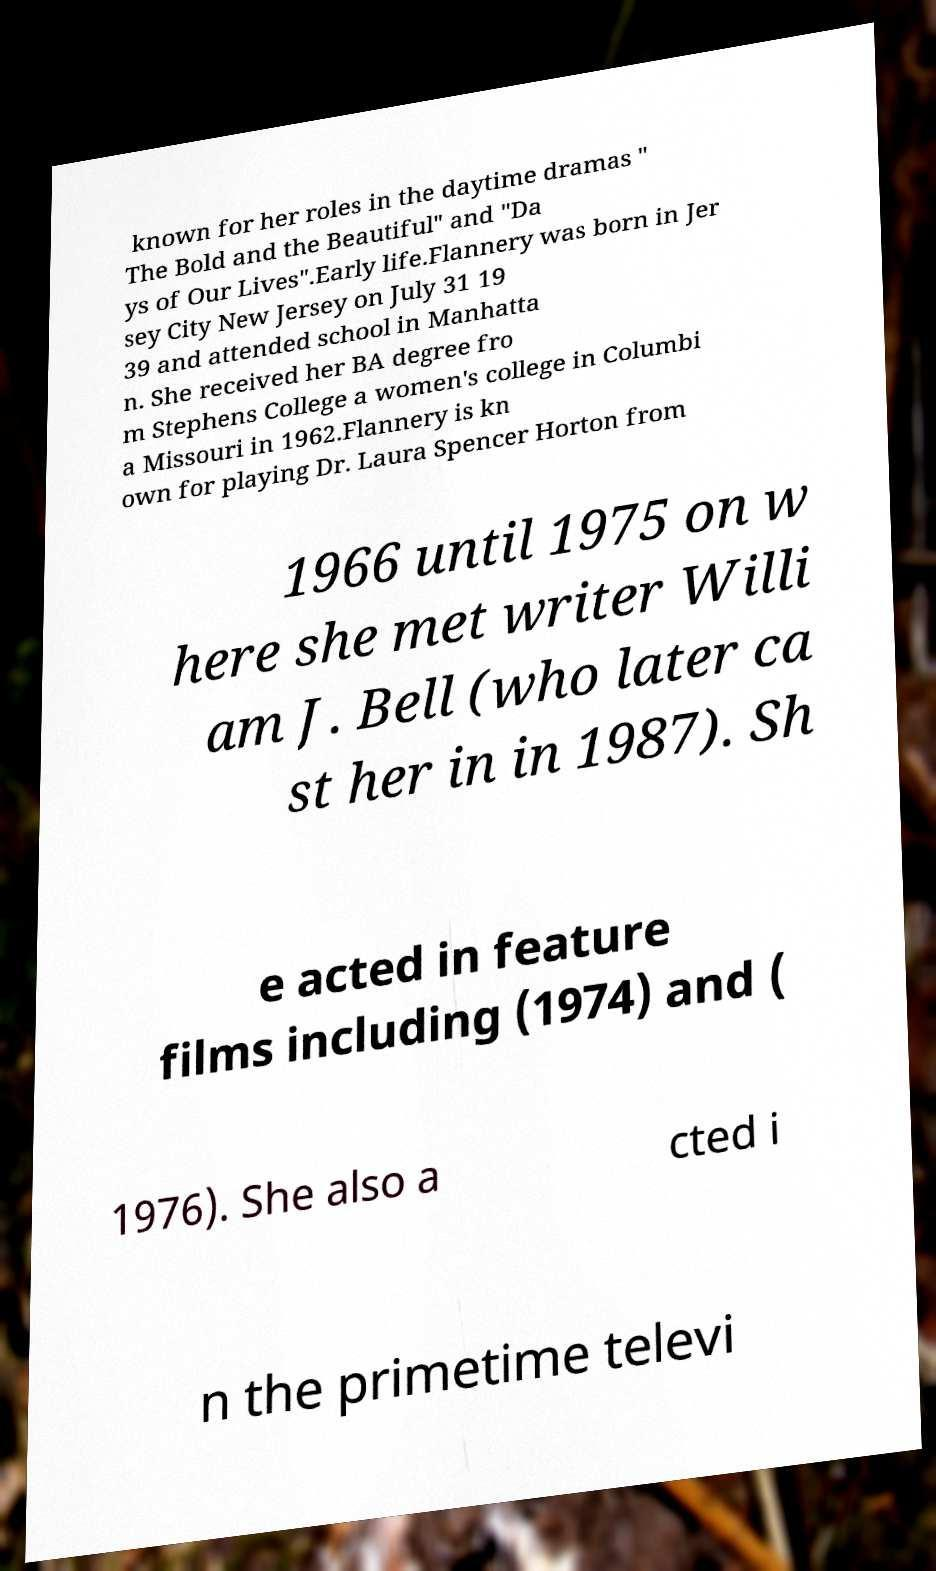Could you extract and type out the text from this image? known for her roles in the daytime dramas " The Bold and the Beautiful" and "Da ys of Our Lives".Early life.Flannery was born in Jer sey City New Jersey on July 31 19 39 and attended school in Manhatta n. She received her BA degree fro m Stephens College a women's college in Columbi a Missouri in 1962.Flannery is kn own for playing Dr. Laura Spencer Horton from 1966 until 1975 on w here she met writer Willi am J. Bell (who later ca st her in in 1987). Sh e acted in feature films including (1974) and ( 1976). She also a cted i n the primetime televi 